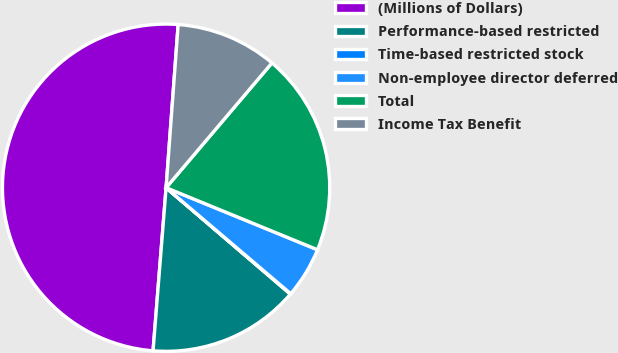Convert chart. <chart><loc_0><loc_0><loc_500><loc_500><pie_chart><fcel>(Millions of Dollars)<fcel>Performance-based restricted<fcel>Time-based restricted stock<fcel>Non-employee director deferred<fcel>Total<fcel>Income Tax Benefit<nl><fcel>49.9%<fcel>15.0%<fcel>0.05%<fcel>5.03%<fcel>19.99%<fcel>10.02%<nl></chart> 